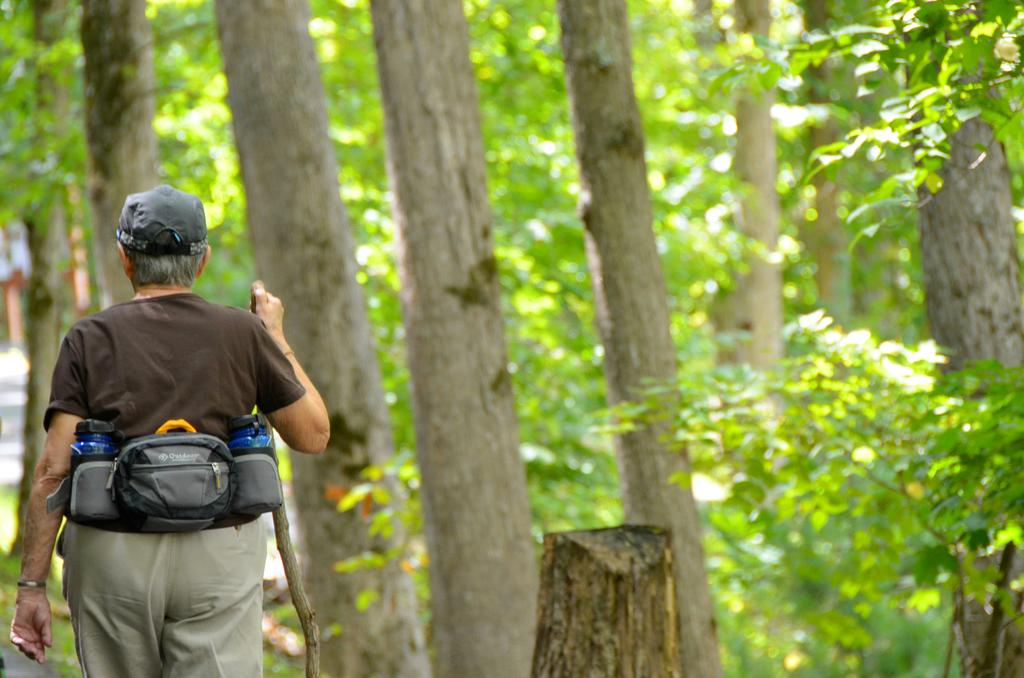What is the main subject of the image? There is a person standing in the image. What is the person holding in their hands? The person is holding a stick in their hands. What is the person wearing that might be used for carrying items? The person is wearing a bag. What type of natural environment can be seen in the image? There are trees visible in the image. What type of berry can be seen growing on the trees in the image? There is no berry visible on the trees in the image; only the trees themselves can be seen. 